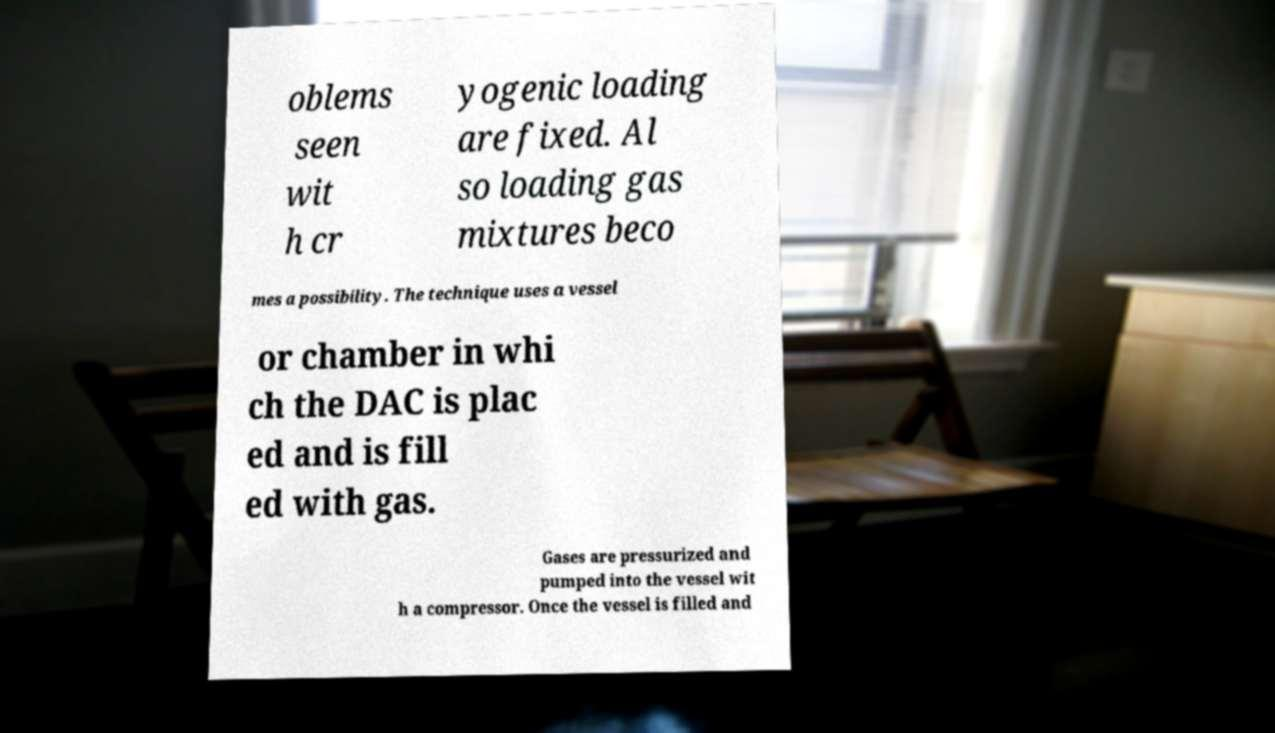Please read and relay the text visible in this image. What does it say? oblems seen wit h cr yogenic loading are fixed. Al so loading gas mixtures beco mes a possibility. The technique uses a vessel or chamber in whi ch the DAC is plac ed and is fill ed with gas. Gases are pressurized and pumped into the vessel wit h a compressor. Once the vessel is filled and 